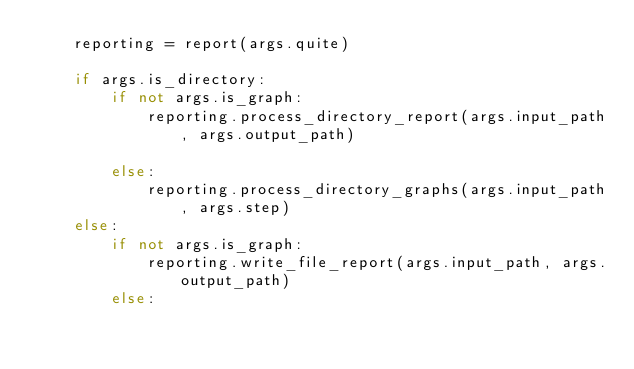<code> <loc_0><loc_0><loc_500><loc_500><_Python_>    reporting = report(args.quite)

    if args.is_directory:
        if not args.is_graph:
            reporting.process_directory_report(args.input_path, args.output_path)
            
        else:
            reporting.process_directory_graphs(args.input_path, args.step)
    else:
        if not args.is_graph:
            reporting.write_file_report(args.input_path, args.output_path)
        else:</code> 